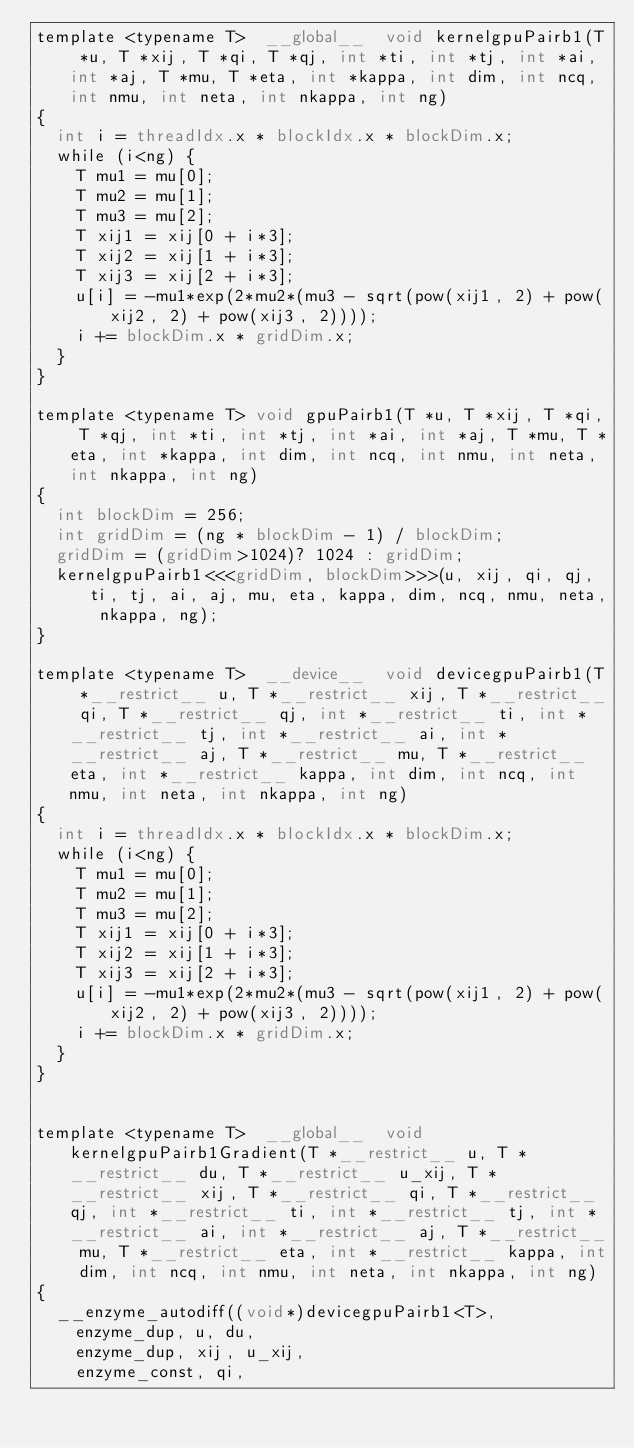Convert code to text. <code><loc_0><loc_0><loc_500><loc_500><_Cuda_>template <typename T>  __global__  void kernelgpuPairb1(T *u, T *xij, T *qi, T *qj, int *ti, int *tj, int *ai, int *aj, T *mu, T *eta, int *kappa, int dim, int ncq, int nmu, int neta, int nkappa, int ng)
{
	int i = threadIdx.x * blockIdx.x * blockDim.x;
	while (i<ng) {
		T mu1 = mu[0];
		T mu2 = mu[1];
		T mu3 = mu[2];
		T xij1 = xij[0 + i*3];
		T xij2 = xij[1 + i*3];
		T xij3 = xij[2 + i*3];
		u[i] = -mu1*exp(2*mu2*(mu3 - sqrt(pow(xij1, 2) + pow(xij2, 2) + pow(xij3, 2))));
		i += blockDim.x * gridDim.x;
	}
}

template <typename T> void gpuPairb1(T *u, T *xij, T *qi, T *qj, int *ti, int *tj, int *ai, int *aj, T *mu, T *eta, int *kappa, int dim, int ncq, int nmu, int neta, int nkappa, int ng)
{
	int blockDim = 256;
	int gridDim = (ng * blockDim - 1) / blockDim;
	gridDim = (gridDim>1024)? 1024 : gridDim;
	kernelgpuPairb1<<<gridDim, blockDim>>>(u, xij, qi, qj, ti, tj, ai, aj, mu, eta, kappa, dim, ncq, nmu, neta, nkappa, ng);
}

template <typename T>  __device__  void devicegpuPairb1(T *__restrict__ u, T *__restrict__ xij, T *__restrict__ qi, T *__restrict__ qj, int *__restrict__ ti, int *__restrict__ tj, int *__restrict__ ai, int *__restrict__ aj, T *__restrict__ mu, T *__restrict__ eta, int *__restrict__ kappa, int dim, int ncq, int nmu, int neta, int nkappa, int ng)
{
	int i = threadIdx.x * blockIdx.x * blockDim.x;
	while (i<ng) {
		T mu1 = mu[0];
		T mu2 = mu[1];
		T mu3 = mu[2];
		T xij1 = xij[0 + i*3];
		T xij2 = xij[1 + i*3];
		T xij3 = xij[2 + i*3];
		u[i] = -mu1*exp(2*mu2*(mu3 - sqrt(pow(xij1, 2) + pow(xij2, 2) + pow(xij3, 2))));
		i += blockDim.x * gridDim.x;
	}
}


template <typename T>  __global__  void kernelgpuPairb1Gradient(T *__restrict__ u, T *__restrict__ du, T *__restrict__ u_xij, T *__restrict__ xij, T *__restrict__ qi, T *__restrict__ qj, int *__restrict__ ti, int *__restrict__ tj, int *__restrict__ ai, int *__restrict__ aj, T *__restrict__ mu, T *__restrict__ eta, int *__restrict__ kappa, int dim, int ncq, int nmu, int neta, int nkappa, int ng)
{
	__enzyme_autodiff((void*)devicegpuPairb1<T>, 
		enzyme_dup, u, du, 
		enzyme_dup, xij, u_xij, 
		enzyme_const, qi, </code> 